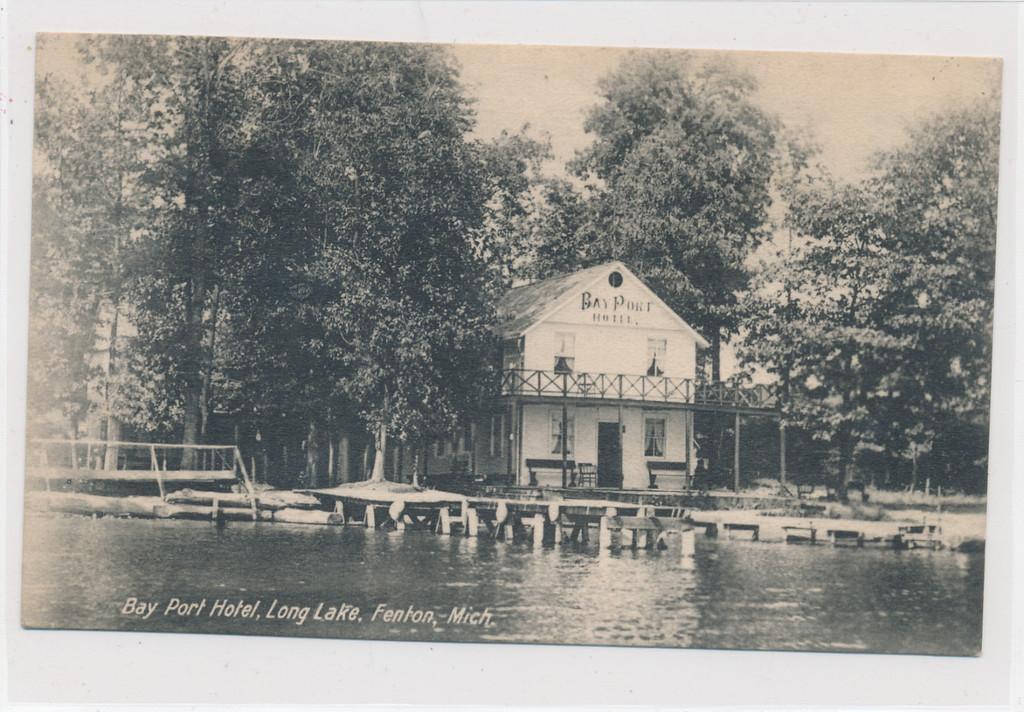In one or two sentences, can you explain what this image depicts? This is a black and white picture, there is a home in the middle with trees on either side of it with a pond in the front of it. 